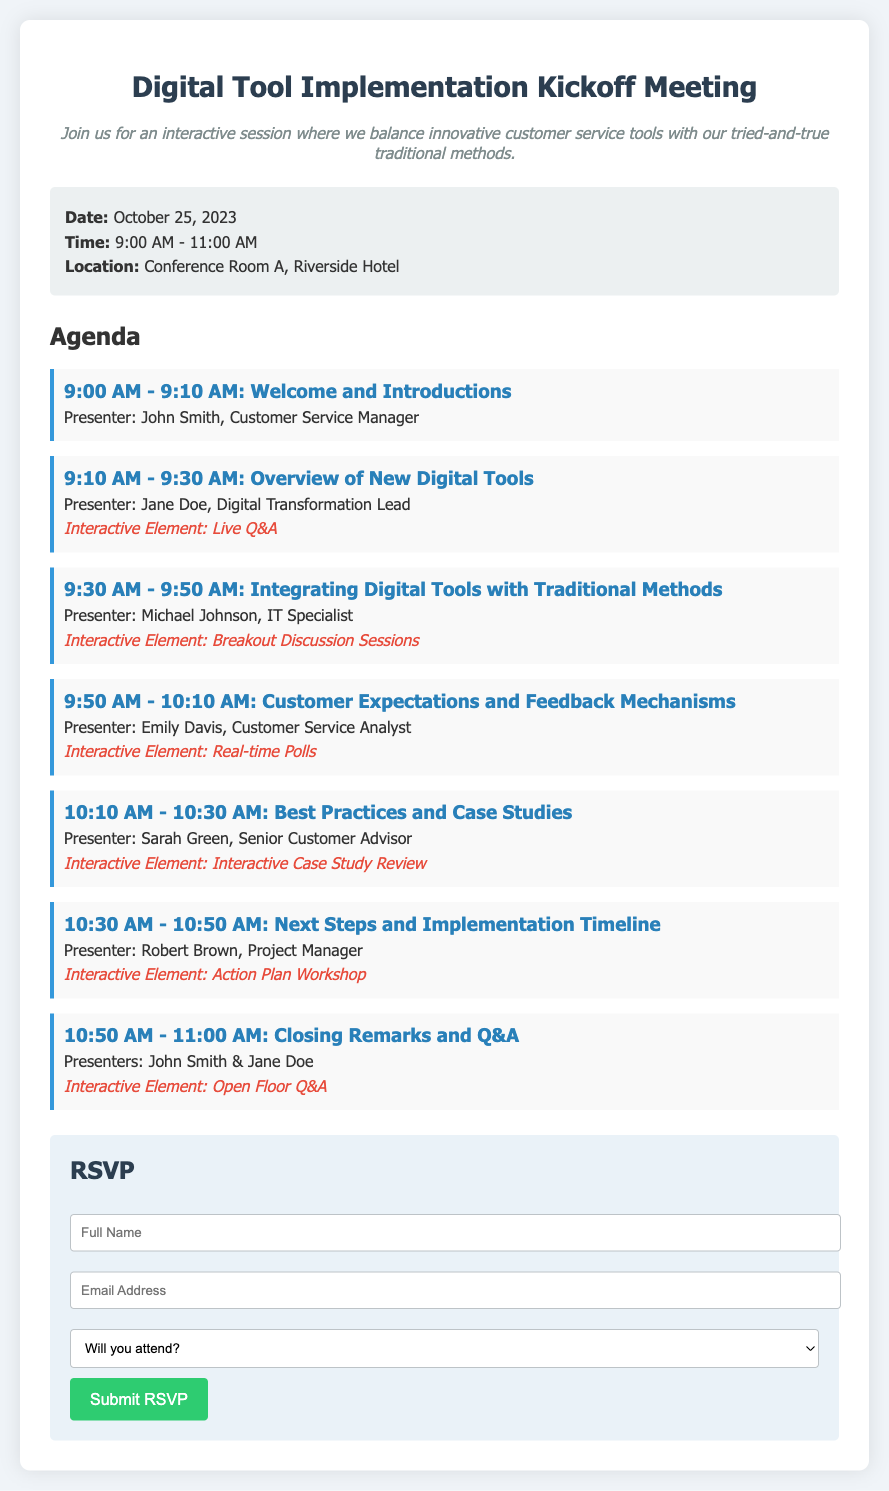What is the date of the meeting? The date of the meeting is explicitly mentioned in the details section of the document.
Answer: October 25, 2023 What is the time of the meeting? The meeting time is specified in the details section of the document.
Answer: 9:00 AM - 11:00 AM Where will the meeting take place? The location is provided in the details section of the document.
Answer: Conference Room A, Riverside Hotel Who is the presenter for the first agenda item? The first agenda item lists the presenter clearly.
Answer: John Smith What type of interactive element will be included during the overview of new digital tools? The document specifies the interactive element for this section.
Answer: Live Q&A How many agenda items are there in total? The document lists the agenda items clearly, allowing for a count.
Answer: 7 What is the title of the third agenda item? The third agenda item is explicitly stated in the agenda section of the document.
Answer: Integrating Digital Tools with Traditional Methods What action is required to RSVP? The RSVP section indicates what action participants should take to respond.
Answer: Submit RSVP What aspect of customer service is discussed in the fourth agenda item? The title and presenter information suggest a focus on customer insights.
Answer: Customer Expectations and Feedback Mechanisms 